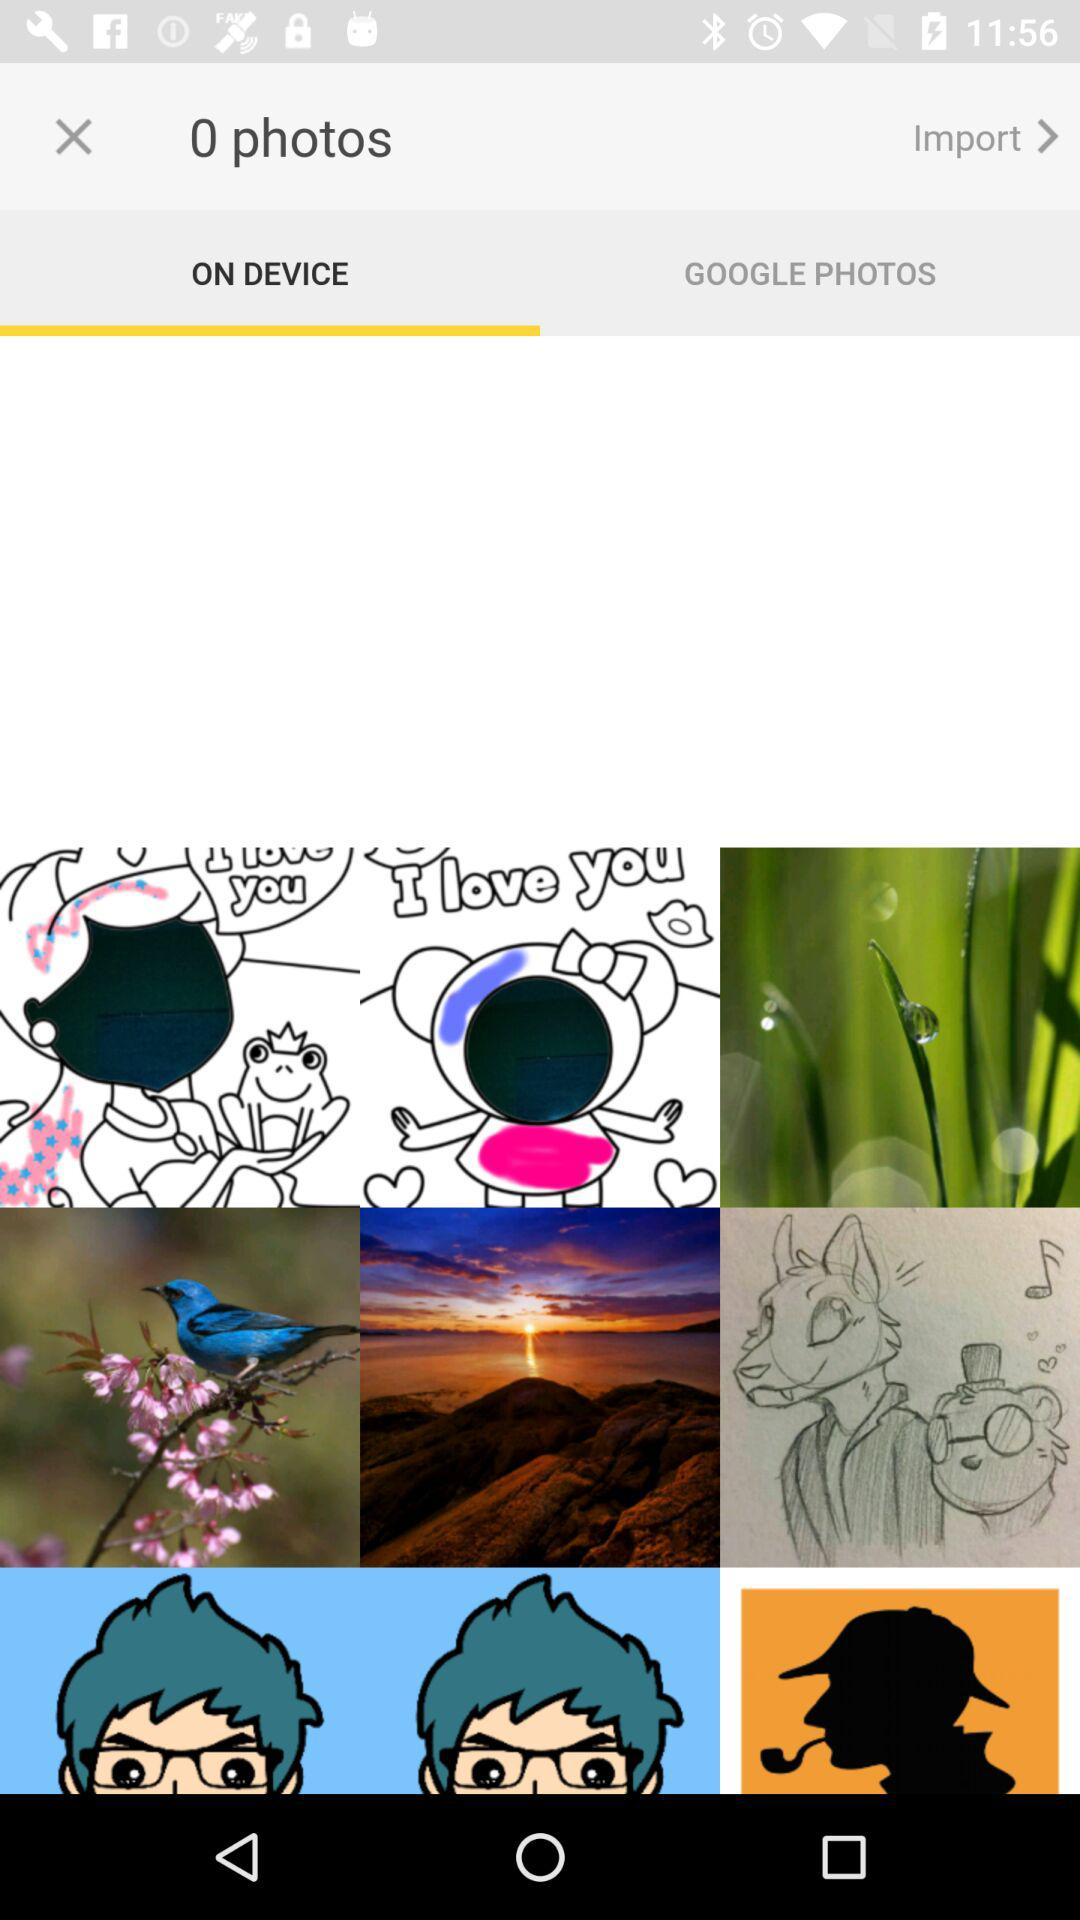How many photos are selected? There are 0 selected photos. 